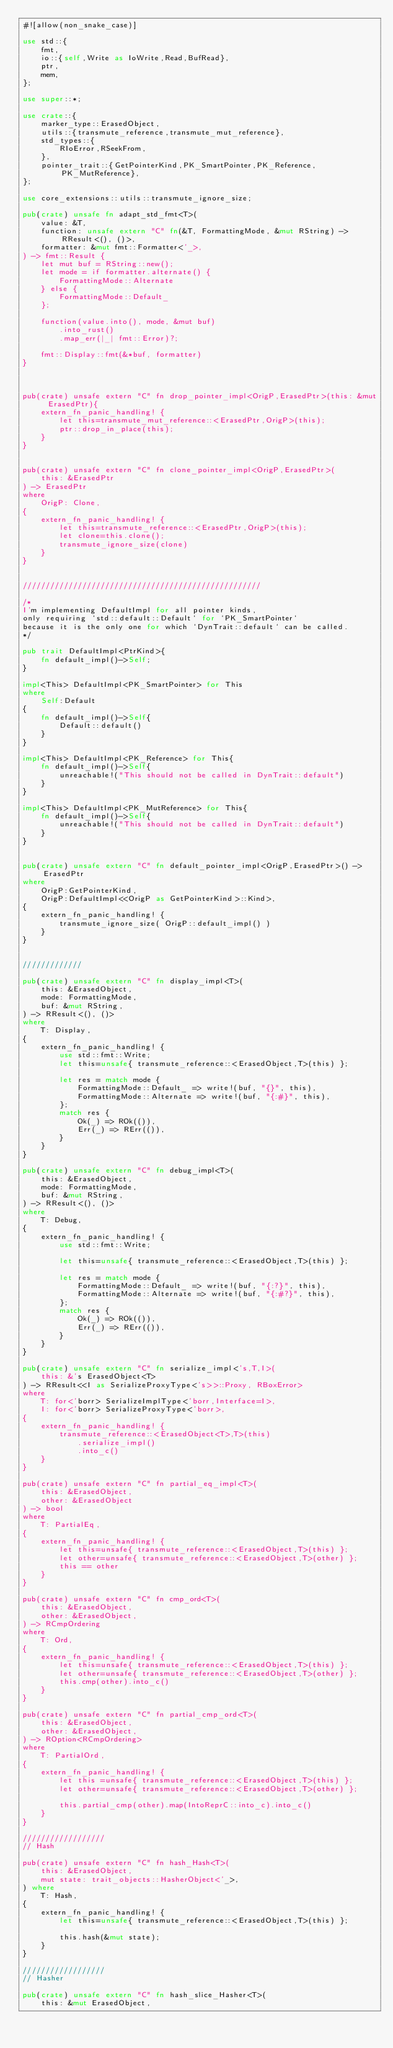Convert code to text. <code><loc_0><loc_0><loc_500><loc_500><_Rust_>#![allow(non_snake_case)]

use std::{
    fmt,
    io::{self,Write as IoWrite,Read,BufRead},
    ptr,
    mem,
};

use super::*;

use crate::{
    marker_type::ErasedObject,
    utils::{transmute_reference,transmute_mut_reference},
    std_types::{
        RIoError,RSeekFrom,
    },
    pointer_trait::{GetPointerKind,PK_SmartPointer,PK_Reference,PK_MutReference},
};

use core_extensions::utils::transmute_ignore_size;

pub(crate) unsafe fn adapt_std_fmt<T>(
    value: &T,
    function: unsafe extern "C" fn(&T, FormattingMode, &mut RString) -> RResult<(), ()>,
    formatter: &mut fmt::Formatter<'_>,
) -> fmt::Result {
    let mut buf = RString::new();
    let mode = if formatter.alternate() {
        FormattingMode::Alternate
    } else {
        FormattingMode::Default_
    };

    function(value.into(), mode, &mut buf)
        .into_rust()
        .map_err(|_| fmt::Error)?;

    fmt::Display::fmt(&*buf, formatter)
}



pub(crate) unsafe extern "C" fn drop_pointer_impl<OrigP,ErasedPtr>(this: &mut ErasedPtr){
    extern_fn_panic_handling! {
        let this=transmute_mut_reference::<ErasedPtr,OrigP>(this);
        ptr::drop_in_place(this);
    }
}


pub(crate) unsafe extern "C" fn clone_pointer_impl<OrigP,ErasedPtr>(
    this: &ErasedPtr
) -> ErasedPtr
where
    OrigP: Clone,
{
    extern_fn_panic_handling! {
        let this=transmute_reference::<ErasedPtr,OrigP>(this);
        let clone=this.clone();
        transmute_ignore_size(clone)
    }
}


////////////////////////////////////////////////////

/*
I'm implementing DefaultImpl for all pointer kinds,
only requiring `std::default::Default` for `PK_SmartPointer`
because it is the only one for which `DynTrait::default` can be called.
*/

pub trait DefaultImpl<PtrKind>{
    fn default_impl()->Self;    
}

impl<This> DefaultImpl<PK_SmartPointer> for This
where 
    Self:Default
{
    fn default_impl()->Self{
        Default::default()
    }
}

impl<This> DefaultImpl<PK_Reference> for This{
    fn default_impl()->Self{
        unreachable!("This should not be called in DynTrait::default")
    }
}

impl<This> DefaultImpl<PK_MutReference> for This{
    fn default_impl()->Self{
        unreachable!("This should not be called in DynTrait::default")
    }
}


pub(crate) unsafe extern "C" fn default_pointer_impl<OrigP,ErasedPtr>() -> ErasedPtr
where
    OrigP:GetPointerKind,
    OrigP:DefaultImpl<<OrigP as GetPointerKind>::Kind>,
{
    extern_fn_panic_handling! {
        transmute_ignore_size( OrigP::default_impl() )
    }
}


/////////////

pub(crate) unsafe extern "C" fn display_impl<T>(
    this: &ErasedObject,
    mode: FormattingMode,
    buf: &mut RString,
) -> RResult<(), ()>
where
    T: Display,
{
    extern_fn_panic_handling! {
        use std::fmt::Write;
        let this=unsafe{ transmute_reference::<ErasedObject,T>(this) };

        let res = match mode {
            FormattingMode::Default_ => write!(buf, "{}", this),
            FormattingMode::Alternate => write!(buf, "{:#}", this),
        };
        match res {
            Ok(_) => ROk(()),
            Err(_) => RErr(()),
        }
    }
}

pub(crate) unsafe extern "C" fn debug_impl<T>(
    this: &ErasedObject,
    mode: FormattingMode,
    buf: &mut RString,
) -> RResult<(), ()>
where
    T: Debug,
{
    extern_fn_panic_handling! {
        use std::fmt::Write;

        let this=unsafe{ transmute_reference::<ErasedObject,T>(this) };

        let res = match mode {
            FormattingMode::Default_ => write!(buf, "{:?}", this),
            FormattingMode::Alternate => write!(buf, "{:#?}", this),
        };
        match res {
            Ok(_) => ROk(()),
            Err(_) => RErr(()),
        }
    }
}

pub(crate) unsafe extern "C" fn serialize_impl<'s,T,I>(
    this: &'s ErasedObject<T>
) -> RResult<<I as SerializeProxyType<'s>>::Proxy, RBoxError>
where
    T: for<'borr> SerializeImplType<'borr,Interface=I>,
    I: for<'borr> SerializeProxyType<'borr>,
{
    extern_fn_panic_handling! {
        transmute_reference::<ErasedObject<T>,T>(this)
            .serialize_impl()
            .into_c()
    }
}

pub(crate) unsafe extern "C" fn partial_eq_impl<T>(
    this: &ErasedObject,
    other: &ErasedObject
) -> bool
where
    T: PartialEq,
{
    extern_fn_panic_handling! {
        let this=unsafe{ transmute_reference::<ErasedObject,T>(this) };
        let other=unsafe{ transmute_reference::<ErasedObject,T>(other) };
        this == other
    }
}

pub(crate) unsafe extern "C" fn cmp_ord<T>(
    this: &ErasedObject,
    other: &ErasedObject,
) -> RCmpOrdering
where
    T: Ord,
{
    extern_fn_panic_handling! {
        let this=unsafe{ transmute_reference::<ErasedObject,T>(this) };
        let other=unsafe{ transmute_reference::<ErasedObject,T>(other) };
        this.cmp(other).into_c()
    }
}

pub(crate) unsafe extern "C" fn partial_cmp_ord<T>(
    this: &ErasedObject, 
    other: &ErasedObject,
) -> ROption<RCmpOrdering>
where
    T: PartialOrd,
{
    extern_fn_panic_handling! {
        let this =unsafe{ transmute_reference::<ErasedObject,T>(this) };
        let other=unsafe{ transmute_reference::<ErasedObject,T>(other) };

        this.partial_cmp(other).map(IntoReprC::into_c).into_c()
    }
}

//////////////////
// Hash

pub(crate) unsafe extern "C" fn hash_Hash<T>(
    this: &ErasedObject,
    mut state: trait_objects::HasherObject<'_>,
) where
    T: Hash,
{
    extern_fn_panic_handling! {
        let this=unsafe{ transmute_reference::<ErasedObject,T>(this) };

        this.hash(&mut state);
    }
}

//////////////////
// Hasher

pub(crate) unsafe extern "C" fn hash_slice_Hasher<T>(
    this: &mut ErasedObject,</code> 